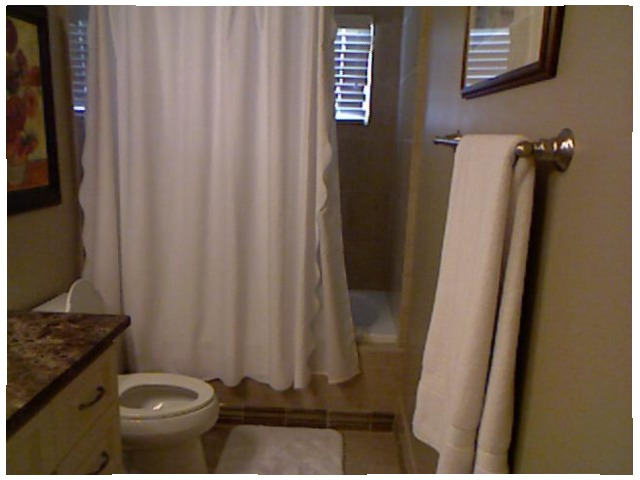<image>
Is there a toilet behind the shower curtain? No. The toilet is not behind the shower curtain. From this viewpoint, the toilet appears to be positioned elsewhere in the scene. 